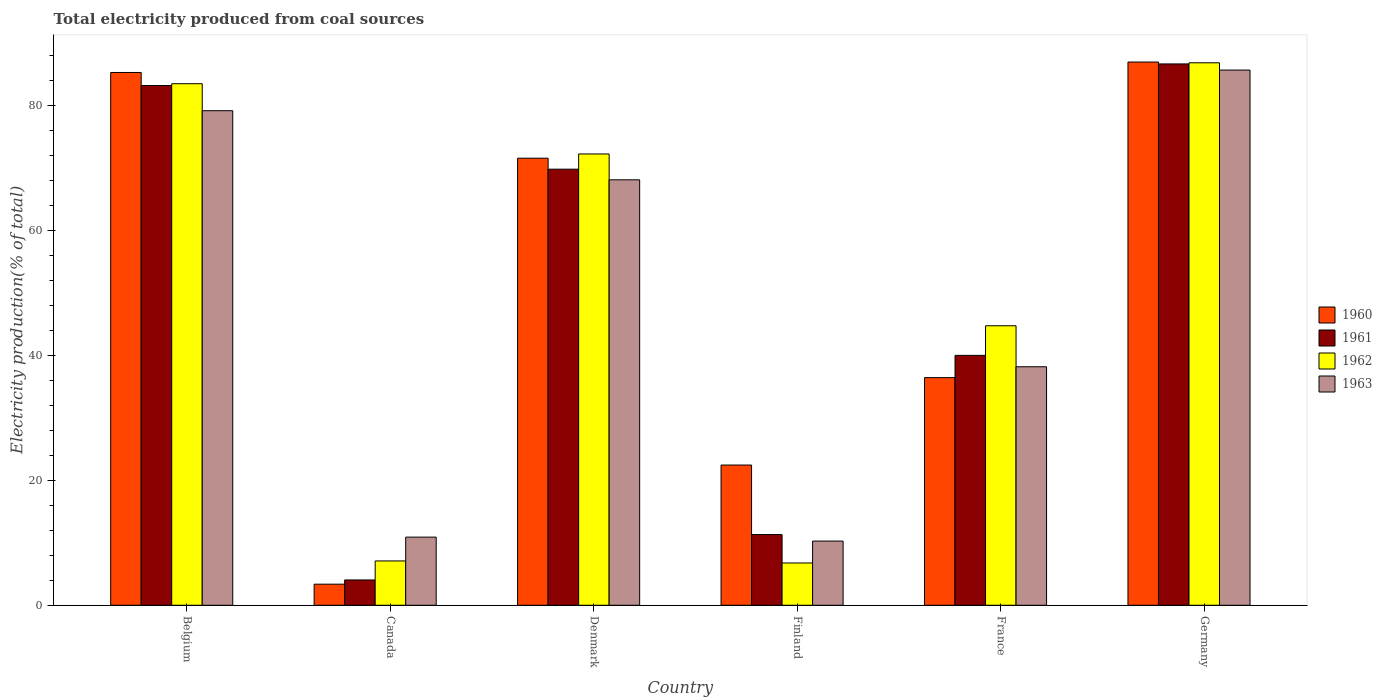How many groups of bars are there?
Ensure brevity in your answer.  6. Are the number of bars per tick equal to the number of legend labels?
Make the answer very short. Yes. Are the number of bars on each tick of the X-axis equal?
Provide a succinct answer. Yes. What is the total electricity produced in 1962 in Finland?
Make the answer very short. 6.78. Across all countries, what is the maximum total electricity produced in 1961?
Your answer should be very brief. 86.73. Across all countries, what is the minimum total electricity produced in 1962?
Give a very brief answer. 6.78. In which country was the total electricity produced in 1963 maximum?
Your answer should be compact. Germany. What is the total total electricity produced in 1963 in the graph?
Offer a very short reply. 292.54. What is the difference between the total electricity produced in 1960 in France and that in Germany?
Provide a short and direct response. -50.56. What is the difference between the total electricity produced in 1960 in Germany and the total electricity produced in 1962 in Canada?
Give a very brief answer. 79.93. What is the average total electricity produced in 1963 per country?
Ensure brevity in your answer.  48.76. What is the difference between the total electricity produced of/in 1961 and total electricity produced of/in 1963 in Germany?
Keep it short and to the point. 0.98. What is the ratio of the total electricity produced in 1961 in France to that in Germany?
Provide a short and direct response. 0.46. Is the total electricity produced in 1963 in Canada less than that in Denmark?
Offer a terse response. Yes. Is the difference between the total electricity produced in 1961 in Finland and Germany greater than the difference between the total electricity produced in 1963 in Finland and Germany?
Provide a short and direct response. Yes. What is the difference between the highest and the second highest total electricity produced in 1961?
Provide a short and direct response. 13.4. What is the difference between the highest and the lowest total electricity produced in 1962?
Provide a succinct answer. 80.13. In how many countries, is the total electricity produced in 1961 greater than the average total electricity produced in 1961 taken over all countries?
Make the answer very short. 3. What does the 4th bar from the left in Finland represents?
Provide a short and direct response. 1963. What does the 2nd bar from the right in Germany represents?
Your answer should be very brief. 1962. Is it the case that in every country, the sum of the total electricity produced in 1960 and total electricity produced in 1962 is greater than the total electricity produced in 1961?
Your answer should be very brief. Yes. How many bars are there?
Your answer should be compact. 24. Are all the bars in the graph horizontal?
Make the answer very short. No. What is the difference between two consecutive major ticks on the Y-axis?
Your answer should be compact. 20. Does the graph contain any zero values?
Give a very brief answer. No. Where does the legend appear in the graph?
Offer a very short reply. Center right. How many legend labels are there?
Your response must be concise. 4. What is the title of the graph?
Keep it short and to the point. Total electricity produced from coal sources. Does "2015" appear as one of the legend labels in the graph?
Your answer should be very brief. No. What is the label or title of the X-axis?
Keep it short and to the point. Country. What is the Electricity production(% of total) of 1960 in Belgium?
Give a very brief answer. 85.36. What is the Electricity production(% of total) in 1961 in Belgium?
Give a very brief answer. 83.27. What is the Electricity production(% of total) in 1962 in Belgium?
Keep it short and to the point. 83.56. What is the Electricity production(% of total) in 1963 in Belgium?
Keep it short and to the point. 79.23. What is the Electricity production(% of total) of 1960 in Canada?
Keep it short and to the point. 3.38. What is the Electricity production(% of total) in 1961 in Canada?
Make the answer very short. 4.05. What is the Electricity production(% of total) in 1962 in Canada?
Offer a very short reply. 7.1. What is the Electricity production(% of total) in 1963 in Canada?
Offer a very short reply. 10.92. What is the Electricity production(% of total) in 1960 in Denmark?
Provide a succinct answer. 71.62. What is the Electricity production(% of total) in 1961 in Denmark?
Give a very brief answer. 69.86. What is the Electricity production(% of total) in 1962 in Denmark?
Your response must be concise. 72.3. What is the Electricity production(% of total) in 1963 in Denmark?
Your answer should be compact. 68.16. What is the Electricity production(% of total) of 1960 in Finland?
Make the answer very short. 22.46. What is the Electricity production(% of total) of 1961 in Finland?
Offer a terse response. 11.33. What is the Electricity production(% of total) of 1962 in Finland?
Provide a succinct answer. 6.78. What is the Electricity production(% of total) of 1963 in Finland?
Offer a terse response. 10.28. What is the Electricity production(% of total) in 1960 in France?
Offer a terse response. 36.47. What is the Electricity production(% of total) in 1961 in France?
Your answer should be very brief. 40.03. What is the Electricity production(% of total) of 1962 in France?
Offer a terse response. 44.78. What is the Electricity production(% of total) in 1963 in France?
Give a very brief answer. 38.21. What is the Electricity production(% of total) in 1960 in Germany?
Provide a succinct answer. 87.03. What is the Electricity production(% of total) in 1961 in Germany?
Offer a terse response. 86.73. What is the Electricity production(% of total) in 1962 in Germany?
Make the answer very short. 86.91. What is the Electricity production(% of total) of 1963 in Germany?
Your answer should be compact. 85.74. Across all countries, what is the maximum Electricity production(% of total) in 1960?
Your response must be concise. 87.03. Across all countries, what is the maximum Electricity production(% of total) in 1961?
Your response must be concise. 86.73. Across all countries, what is the maximum Electricity production(% of total) in 1962?
Make the answer very short. 86.91. Across all countries, what is the maximum Electricity production(% of total) of 1963?
Ensure brevity in your answer.  85.74. Across all countries, what is the minimum Electricity production(% of total) in 1960?
Your response must be concise. 3.38. Across all countries, what is the minimum Electricity production(% of total) in 1961?
Provide a short and direct response. 4.05. Across all countries, what is the minimum Electricity production(% of total) of 1962?
Make the answer very short. 6.78. Across all countries, what is the minimum Electricity production(% of total) in 1963?
Offer a very short reply. 10.28. What is the total Electricity production(% of total) of 1960 in the graph?
Keep it short and to the point. 306.32. What is the total Electricity production(% of total) in 1961 in the graph?
Ensure brevity in your answer.  295.27. What is the total Electricity production(% of total) of 1962 in the graph?
Your answer should be compact. 301.42. What is the total Electricity production(% of total) in 1963 in the graph?
Provide a succinct answer. 292.55. What is the difference between the Electricity production(% of total) in 1960 in Belgium and that in Canada?
Offer a terse response. 81.98. What is the difference between the Electricity production(% of total) of 1961 in Belgium and that in Canada?
Provide a succinct answer. 79.21. What is the difference between the Electricity production(% of total) in 1962 in Belgium and that in Canada?
Give a very brief answer. 76.46. What is the difference between the Electricity production(% of total) in 1963 in Belgium and that in Canada?
Your answer should be very brief. 68.31. What is the difference between the Electricity production(% of total) of 1960 in Belgium and that in Denmark?
Provide a succinct answer. 13.73. What is the difference between the Electricity production(% of total) in 1961 in Belgium and that in Denmark?
Keep it short and to the point. 13.4. What is the difference between the Electricity production(% of total) of 1962 in Belgium and that in Denmark?
Ensure brevity in your answer.  11.26. What is the difference between the Electricity production(% of total) in 1963 in Belgium and that in Denmark?
Keep it short and to the point. 11.07. What is the difference between the Electricity production(% of total) of 1960 in Belgium and that in Finland?
Your response must be concise. 62.89. What is the difference between the Electricity production(% of total) in 1961 in Belgium and that in Finland?
Offer a terse response. 71.94. What is the difference between the Electricity production(% of total) of 1962 in Belgium and that in Finland?
Make the answer very short. 76.78. What is the difference between the Electricity production(% of total) of 1963 in Belgium and that in Finland?
Provide a succinct answer. 68.95. What is the difference between the Electricity production(% of total) of 1960 in Belgium and that in France?
Offer a terse response. 48.89. What is the difference between the Electricity production(% of total) of 1961 in Belgium and that in France?
Provide a succinct answer. 43.23. What is the difference between the Electricity production(% of total) in 1962 in Belgium and that in France?
Your response must be concise. 38.78. What is the difference between the Electricity production(% of total) of 1963 in Belgium and that in France?
Your answer should be compact. 41.02. What is the difference between the Electricity production(% of total) of 1960 in Belgium and that in Germany?
Make the answer very short. -1.67. What is the difference between the Electricity production(% of total) of 1961 in Belgium and that in Germany?
Provide a succinct answer. -3.46. What is the difference between the Electricity production(% of total) of 1962 in Belgium and that in Germany?
Make the answer very short. -3.35. What is the difference between the Electricity production(% of total) in 1963 in Belgium and that in Germany?
Provide a short and direct response. -6.51. What is the difference between the Electricity production(% of total) in 1960 in Canada and that in Denmark?
Make the answer very short. -68.25. What is the difference between the Electricity production(% of total) in 1961 in Canada and that in Denmark?
Make the answer very short. -65.81. What is the difference between the Electricity production(% of total) of 1962 in Canada and that in Denmark?
Provide a succinct answer. -65.2. What is the difference between the Electricity production(% of total) of 1963 in Canada and that in Denmark?
Provide a short and direct response. -57.24. What is the difference between the Electricity production(% of total) in 1960 in Canada and that in Finland?
Your answer should be compact. -19.09. What is the difference between the Electricity production(% of total) of 1961 in Canada and that in Finland?
Offer a terse response. -7.27. What is the difference between the Electricity production(% of total) of 1962 in Canada and that in Finland?
Provide a succinct answer. 0.32. What is the difference between the Electricity production(% of total) of 1963 in Canada and that in Finland?
Give a very brief answer. 0.63. What is the difference between the Electricity production(% of total) of 1960 in Canada and that in France?
Keep it short and to the point. -33.09. What is the difference between the Electricity production(% of total) of 1961 in Canada and that in France?
Provide a succinct answer. -35.98. What is the difference between the Electricity production(% of total) in 1962 in Canada and that in France?
Provide a succinct answer. -37.68. What is the difference between the Electricity production(% of total) of 1963 in Canada and that in France?
Ensure brevity in your answer.  -27.29. What is the difference between the Electricity production(% of total) in 1960 in Canada and that in Germany?
Ensure brevity in your answer.  -83.65. What is the difference between the Electricity production(% of total) in 1961 in Canada and that in Germany?
Your answer should be very brief. -82.67. What is the difference between the Electricity production(% of total) in 1962 in Canada and that in Germany?
Your answer should be very brief. -79.81. What is the difference between the Electricity production(% of total) of 1963 in Canada and that in Germany?
Offer a terse response. -74.83. What is the difference between the Electricity production(% of total) of 1960 in Denmark and that in Finland?
Ensure brevity in your answer.  49.16. What is the difference between the Electricity production(% of total) of 1961 in Denmark and that in Finland?
Keep it short and to the point. 58.54. What is the difference between the Electricity production(% of total) in 1962 in Denmark and that in Finland?
Provide a short and direct response. 65.53. What is the difference between the Electricity production(% of total) in 1963 in Denmark and that in Finland?
Ensure brevity in your answer.  57.88. What is the difference between the Electricity production(% of total) of 1960 in Denmark and that in France?
Keep it short and to the point. 35.16. What is the difference between the Electricity production(% of total) of 1961 in Denmark and that in France?
Offer a terse response. 29.83. What is the difference between the Electricity production(% of total) in 1962 in Denmark and that in France?
Offer a very short reply. 27.52. What is the difference between the Electricity production(% of total) of 1963 in Denmark and that in France?
Your response must be concise. 29.95. What is the difference between the Electricity production(% of total) in 1960 in Denmark and that in Germany?
Provide a short and direct response. -15.4. What is the difference between the Electricity production(% of total) in 1961 in Denmark and that in Germany?
Provide a succinct answer. -16.86. What is the difference between the Electricity production(% of total) of 1962 in Denmark and that in Germany?
Your answer should be compact. -14.61. What is the difference between the Electricity production(% of total) of 1963 in Denmark and that in Germany?
Keep it short and to the point. -17.58. What is the difference between the Electricity production(% of total) of 1960 in Finland and that in France?
Ensure brevity in your answer.  -14.01. What is the difference between the Electricity production(% of total) in 1961 in Finland and that in France?
Your answer should be compact. -28.71. What is the difference between the Electricity production(% of total) in 1962 in Finland and that in France?
Provide a succinct answer. -38. What is the difference between the Electricity production(% of total) of 1963 in Finland and that in France?
Your response must be concise. -27.93. What is the difference between the Electricity production(% of total) in 1960 in Finland and that in Germany?
Give a very brief answer. -64.57. What is the difference between the Electricity production(% of total) of 1961 in Finland and that in Germany?
Provide a succinct answer. -75.4. What is the difference between the Electricity production(% of total) in 1962 in Finland and that in Germany?
Keep it short and to the point. -80.13. What is the difference between the Electricity production(% of total) of 1963 in Finland and that in Germany?
Your answer should be very brief. -75.46. What is the difference between the Electricity production(% of total) in 1960 in France and that in Germany?
Your answer should be very brief. -50.56. What is the difference between the Electricity production(% of total) of 1961 in France and that in Germany?
Your answer should be very brief. -46.69. What is the difference between the Electricity production(% of total) in 1962 in France and that in Germany?
Ensure brevity in your answer.  -42.13. What is the difference between the Electricity production(% of total) of 1963 in France and that in Germany?
Your answer should be compact. -47.53. What is the difference between the Electricity production(% of total) of 1960 in Belgium and the Electricity production(% of total) of 1961 in Canada?
Provide a short and direct response. 81.3. What is the difference between the Electricity production(% of total) in 1960 in Belgium and the Electricity production(% of total) in 1962 in Canada?
Provide a short and direct response. 78.26. What is the difference between the Electricity production(% of total) of 1960 in Belgium and the Electricity production(% of total) of 1963 in Canada?
Your answer should be very brief. 74.44. What is the difference between the Electricity production(% of total) of 1961 in Belgium and the Electricity production(% of total) of 1962 in Canada?
Provide a succinct answer. 76.17. What is the difference between the Electricity production(% of total) of 1961 in Belgium and the Electricity production(% of total) of 1963 in Canada?
Your answer should be compact. 72.35. What is the difference between the Electricity production(% of total) in 1962 in Belgium and the Electricity production(% of total) in 1963 in Canada?
Give a very brief answer. 72.64. What is the difference between the Electricity production(% of total) of 1960 in Belgium and the Electricity production(% of total) of 1961 in Denmark?
Keep it short and to the point. 15.49. What is the difference between the Electricity production(% of total) of 1960 in Belgium and the Electricity production(% of total) of 1962 in Denmark?
Your answer should be very brief. 13.05. What is the difference between the Electricity production(% of total) of 1960 in Belgium and the Electricity production(% of total) of 1963 in Denmark?
Your response must be concise. 17.19. What is the difference between the Electricity production(% of total) of 1961 in Belgium and the Electricity production(% of total) of 1962 in Denmark?
Your answer should be very brief. 10.97. What is the difference between the Electricity production(% of total) in 1961 in Belgium and the Electricity production(% of total) in 1963 in Denmark?
Your answer should be compact. 15.11. What is the difference between the Electricity production(% of total) of 1962 in Belgium and the Electricity production(% of total) of 1963 in Denmark?
Offer a very short reply. 15.4. What is the difference between the Electricity production(% of total) in 1960 in Belgium and the Electricity production(% of total) in 1961 in Finland?
Provide a short and direct response. 74.03. What is the difference between the Electricity production(% of total) in 1960 in Belgium and the Electricity production(% of total) in 1962 in Finland?
Keep it short and to the point. 78.58. What is the difference between the Electricity production(% of total) in 1960 in Belgium and the Electricity production(% of total) in 1963 in Finland?
Your answer should be compact. 75.07. What is the difference between the Electricity production(% of total) of 1961 in Belgium and the Electricity production(% of total) of 1962 in Finland?
Provide a short and direct response. 76.49. What is the difference between the Electricity production(% of total) of 1961 in Belgium and the Electricity production(% of total) of 1963 in Finland?
Your answer should be very brief. 72.98. What is the difference between the Electricity production(% of total) in 1962 in Belgium and the Electricity production(% of total) in 1963 in Finland?
Your response must be concise. 73.27. What is the difference between the Electricity production(% of total) in 1960 in Belgium and the Electricity production(% of total) in 1961 in France?
Ensure brevity in your answer.  45.32. What is the difference between the Electricity production(% of total) in 1960 in Belgium and the Electricity production(% of total) in 1962 in France?
Provide a succinct answer. 40.58. What is the difference between the Electricity production(% of total) of 1960 in Belgium and the Electricity production(% of total) of 1963 in France?
Provide a succinct answer. 47.14. What is the difference between the Electricity production(% of total) of 1961 in Belgium and the Electricity production(% of total) of 1962 in France?
Keep it short and to the point. 38.49. What is the difference between the Electricity production(% of total) of 1961 in Belgium and the Electricity production(% of total) of 1963 in France?
Provide a short and direct response. 45.06. What is the difference between the Electricity production(% of total) in 1962 in Belgium and the Electricity production(% of total) in 1963 in France?
Offer a terse response. 45.35. What is the difference between the Electricity production(% of total) of 1960 in Belgium and the Electricity production(% of total) of 1961 in Germany?
Offer a terse response. -1.37. What is the difference between the Electricity production(% of total) of 1960 in Belgium and the Electricity production(% of total) of 1962 in Germany?
Provide a short and direct response. -1.55. What is the difference between the Electricity production(% of total) of 1960 in Belgium and the Electricity production(% of total) of 1963 in Germany?
Ensure brevity in your answer.  -0.39. What is the difference between the Electricity production(% of total) of 1961 in Belgium and the Electricity production(% of total) of 1962 in Germany?
Your answer should be compact. -3.64. What is the difference between the Electricity production(% of total) of 1961 in Belgium and the Electricity production(% of total) of 1963 in Germany?
Offer a terse response. -2.47. What is the difference between the Electricity production(% of total) in 1962 in Belgium and the Electricity production(% of total) in 1963 in Germany?
Your response must be concise. -2.19. What is the difference between the Electricity production(% of total) in 1960 in Canada and the Electricity production(% of total) in 1961 in Denmark?
Keep it short and to the point. -66.49. What is the difference between the Electricity production(% of total) of 1960 in Canada and the Electricity production(% of total) of 1962 in Denmark?
Keep it short and to the point. -68.92. What is the difference between the Electricity production(% of total) in 1960 in Canada and the Electricity production(% of total) in 1963 in Denmark?
Provide a short and direct response. -64.78. What is the difference between the Electricity production(% of total) in 1961 in Canada and the Electricity production(% of total) in 1962 in Denmark?
Provide a short and direct response. -68.25. What is the difference between the Electricity production(% of total) of 1961 in Canada and the Electricity production(% of total) of 1963 in Denmark?
Your response must be concise. -64.11. What is the difference between the Electricity production(% of total) in 1962 in Canada and the Electricity production(% of total) in 1963 in Denmark?
Keep it short and to the point. -61.06. What is the difference between the Electricity production(% of total) in 1960 in Canada and the Electricity production(% of total) in 1961 in Finland?
Your answer should be very brief. -7.95. What is the difference between the Electricity production(% of total) of 1960 in Canada and the Electricity production(% of total) of 1962 in Finland?
Your response must be concise. -3.4. What is the difference between the Electricity production(% of total) in 1960 in Canada and the Electricity production(% of total) in 1963 in Finland?
Your response must be concise. -6.91. What is the difference between the Electricity production(% of total) of 1961 in Canada and the Electricity production(% of total) of 1962 in Finland?
Your response must be concise. -2.72. What is the difference between the Electricity production(% of total) in 1961 in Canada and the Electricity production(% of total) in 1963 in Finland?
Ensure brevity in your answer.  -6.23. What is the difference between the Electricity production(% of total) of 1962 in Canada and the Electricity production(% of total) of 1963 in Finland?
Make the answer very short. -3.18. What is the difference between the Electricity production(% of total) of 1960 in Canada and the Electricity production(% of total) of 1961 in France?
Provide a short and direct response. -36.66. What is the difference between the Electricity production(% of total) in 1960 in Canada and the Electricity production(% of total) in 1962 in France?
Keep it short and to the point. -41.4. What is the difference between the Electricity production(% of total) of 1960 in Canada and the Electricity production(% of total) of 1963 in France?
Your response must be concise. -34.83. What is the difference between the Electricity production(% of total) of 1961 in Canada and the Electricity production(% of total) of 1962 in France?
Your answer should be compact. -40.72. What is the difference between the Electricity production(% of total) of 1961 in Canada and the Electricity production(% of total) of 1963 in France?
Give a very brief answer. -34.16. What is the difference between the Electricity production(% of total) in 1962 in Canada and the Electricity production(% of total) in 1963 in France?
Your answer should be compact. -31.11. What is the difference between the Electricity production(% of total) in 1960 in Canada and the Electricity production(% of total) in 1961 in Germany?
Make the answer very short. -83.35. What is the difference between the Electricity production(% of total) of 1960 in Canada and the Electricity production(% of total) of 1962 in Germany?
Provide a short and direct response. -83.53. What is the difference between the Electricity production(% of total) in 1960 in Canada and the Electricity production(% of total) in 1963 in Germany?
Ensure brevity in your answer.  -82.36. What is the difference between the Electricity production(% of total) of 1961 in Canada and the Electricity production(% of total) of 1962 in Germany?
Provide a short and direct response. -82.86. What is the difference between the Electricity production(% of total) of 1961 in Canada and the Electricity production(% of total) of 1963 in Germany?
Make the answer very short. -81.69. What is the difference between the Electricity production(% of total) in 1962 in Canada and the Electricity production(% of total) in 1963 in Germany?
Keep it short and to the point. -78.64. What is the difference between the Electricity production(% of total) of 1960 in Denmark and the Electricity production(% of total) of 1961 in Finland?
Offer a very short reply. 60.3. What is the difference between the Electricity production(% of total) of 1960 in Denmark and the Electricity production(% of total) of 1962 in Finland?
Your answer should be compact. 64.85. What is the difference between the Electricity production(% of total) of 1960 in Denmark and the Electricity production(% of total) of 1963 in Finland?
Offer a terse response. 61.34. What is the difference between the Electricity production(% of total) of 1961 in Denmark and the Electricity production(% of total) of 1962 in Finland?
Offer a very short reply. 63.09. What is the difference between the Electricity production(% of total) in 1961 in Denmark and the Electricity production(% of total) in 1963 in Finland?
Ensure brevity in your answer.  59.58. What is the difference between the Electricity production(% of total) in 1962 in Denmark and the Electricity production(% of total) in 1963 in Finland?
Ensure brevity in your answer.  62.02. What is the difference between the Electricity production(% of total) of 1960 in Denmark and the Electricity production(% of total) of 1961 in France?
Make the answer very short. 31.59. What is the difference between the Electricity production(% of total) in 1960 in Denmark and the Electricity production(% of total) in 1962 in France?
Provide a succinct answer. 26.85. What is the difference between the Electricity production(% of total) in 1960 in Denmark and the Electricity production(% of total) in 1963 in France?
Ensure brevity in your answer.  33.41. What is the difference between the Electricity production(% of total) of 1961 in Denmark and the Electricity production(% of total) of 1962 in France?
Offer a terse response. 25.09. What is the difference between the Electricity production(% of total) of 1961 in Denmark and the Electricity production(% of total) of 1963 in France?
Provide a succinct answer. 31.65. What is the difference between the Electricity production(% of total) in 1962 in Denmark and the Electricity production(% of total) in 1963 in France?
Make the answer very short. 34.09. What is the difference between the Electricity production(% of total) in 1960 in Denmark and the Electricity production(% of total) in 1961 in Germany?
Your answer should be compact. -15.1. What is the difference between the Electricity production(% of total) in 1960 in Denmark and the Electricity production(% of total) in 1962 in Germany?
Your answer should be compact. -15.28. What is the difference between the Electricity production(% of total) of 1960 in Denmark and the Electricity production(% of total) of 1963 in Germany?
Give a very brief answer. -14.12. What is the difference between the Electricity production(% of total) in 1961 in Denmark and the Electricity production(% of total) in 1962 in Germany?
Offer a terse response. -17.04. What is the difference between the Electricity production(% of total) in 1961 in Denmark and the Electricity production(% of total) in 1963 in Germany?
Offer a very short reply. -15.88. What is the difference between the Electricity production(% of total) of 1962 in Denmark and the Electricity production(% of total) of 1963 in Germany?
Offer a very short reply. -13.44. What is the difference between the Electricity production(% of total) in 1960 in Finland and the Electricity production(% of total) in 1961 in France?
Your answer should be very brief. -17.57. What is the difference between the Electricity production(% of total) in 1960 in Finland and the Electricity production(% of total) in 1962 in France?
Offer a terse response. -22.31. What is the difference between the Electricity production(% of total) of 1960 in Finland and the Electricity production(% of total) of 1963 in France?
Give a very brief answer. -15.75. What is the difference between the Electricity production(% of total) in 1961 in Finland and the Electricity production(% of total) in 1962 in France?
Offer a very short reply. -33.45. What is the difference between the Electricity production(% of total) in 1961 in Finland and the Electricity production(% of total) in 1963 in France?
Keep it short and to the point. -26.88. What is the difference between the Electricity production(% of total) in 1962 in Finland and the Electricity production(% of total) in 1963 in France?
Ensure brevity in your answer.  -31.44. What is the difference between the Electricity production(% of total) of 1960 in Finland and the Electricity production(% of total) of 1961 in Germany?
Your answer should be very brief. -64.26. What is the difference between the Electricity production(% of total) in 1960 in Finland and the Electricity production(% of total) in 1962 in Germany?
Make the answer very short. -64.45. What is the difference between the Electricity production(% of total) in 1960 in Finland and the Electricity production(% of total) in 1963 in Germany?
Provide a short and direct response. -63.28. What is the difference between the Electricity production(% of total) in 1961 in Finland and the Electricity production(% of total) in 1962 in Germany?
Provide a succinct answer. -75.58. What is the difference between the Electricity production(% of total) of 1961 in Finland and the Electricity production(% of total) of 1963 in Germany?
Your response must be concise. -74.41. What is the difference between the Electricity production(% of total) in 1962 in Finland and the Electricity production(% of total) in 1963 in Germany?
Your response must be concise. -78.97. What is the difference between the Electricity production(% of total) in 1960 in France and the Electricity production(% of total) in 1961 in Germany?
Provide a succinct answer. -50.26. What is the difference between the Electricity production(% of total) of 1960 in France and the Electricity production(% of total) of 1962 in Germany?
Give a very brief answer. -50.44. What is the difference between the Electricity production(% of total) of 1960 in France and the Electricity production(% of total) of 1963 in Germany?
Provide a succinct answer. -49.27. What is the difference between the Electricity production(% of total) of 1961 in France and the Electricity production(% of total) of 1962 in Germany?
Keep it short and to the point. -46.87. What is the difference between the Electricity production(% of total) of 1961 in France and the Electricity production(% of total) of 1963 in Germany?
Ensure brevity in your answer.  -45.71. What is the difference between the Electricity production(% of total) in 1962 in France and the Electricity production(% of total) in 1963 in Germany?
Provide a short and direct response. -40.97. What is the average Electricity production(% of total) of 1960 per country?
Give a very brief answer. 51.05. What is the average Electricity production(% of total) in 1961 per country?
Ensure brevity in your answer.  49.21. What is the average Electricity production(% of total) of 1962 per country?
Offer a very short reply. 50.24. What is the average Electricity production(% of total) of 1963 per country?
Offer a very short reply. 48.76. What is the difference between the Electricity production(% of total) in 1960 and Electricity production(% of total) in 1961 in Belgium?
Make the answer very short. 2.09. What is the difference between the Electricity production(% of total) in 1960 and Electricity production(% of total) in 1962 in Belgium?
Give a very brief answer. 1.8. What is the difference between the Electricity production(% of total) of 1960 and Electricity production(% of total) of 1963 in Belgium?
Make the answer very short. 6.12. What is the difference between the Electricity production(% of total) in 1961 and Electricity production(% of total) in 1962 in Belgium?
Your response must be concise. -0.29. What is the difference between the Electricity production(% of total) in 1961 and Electricity production(% of total) in 1963 in Belgium?
Give a very brief answer. 4.04. What is the difference between the Electricity production(% of total) in 1962 and Electricity production(% of total) in 1963 in Belgium?
Offer a terse response. 4.33. What is the difference between the Electricity production(% of total) of 1960 and Electricity production(% of total) of 1961 in Canada?
Keep it short and to the point. -0.68. What is the difference between the Electricity production(% of total) in 1960 and Electricity production(% of total) in 1962 in Canada?
Your answer should be compact. -3.72. What is the difference between the Electricity production(% of total) in 1960 and Electricity production(% of total) in 1963 in Canada?
Give a very brief answer. -7.54. What is the difference between the Electricity production(% of total) of 1961 and Electricity production(% of total) of 1962 in Canada?
Your response must be concise. -3.04. What is the difference between the Electricity production(% of total) in 1961 and Electricity production(% of total) in 1963 in Canada?
Your answer should be very brief. -6.86. What is the difference between the Electricity production(% of total) of 1962 and Electricity production(% of total) of 1963 in Canada?
Provide a succinct answer. -3.82. What is the difference between the Electricity production(% of total) of 1960 and Electricity production(% of total) of 1961 in Denmark?
Your response must be concise. 1.76. What is the difference between the Electricity production(% of total) of 1960 and Electricity production(% of total) of 1962 in Denmark?
Offer a very short reply. -0.68. What is the difference between the Electricity production(% of total) of 1960 and Electricity production(% of total) of 1963 in Denmark?
Provide a succinct answer. 3.46. What is the difference between the Electricity production(% of total) of 1961 and Electricity production(% of total) of 1962 in Denmark?
Offer a terse response. -2.44. What is the difference between the Electricity production(% of total) of 1961 and Electricity production(% of total) of 1963 in Denmark?
Offer a very short reply. 1.7. What is the difference between the Electricity production(% of total) of 1962 and Electricity production(% of total) of 1963 in Denmark?
Your answer should be very brief. 4.14. What is the difference between the Electricity production(% of total) of 1960 and Electricity production(% of total) of 1961 in Finland?
Provide a succinct answer. 11.14. What is the difference between the Electricity production(% of total) of 1960 and Electricity production(% of total) of 1962 in Finland?
Give a very brief answer. 15.69. What is the difference between the Electricity production(% of total) in 1960 and Electricity production(% of total) in 1963 in Finland?
Ensure brevity in your answer.  12.18. What is the difference between the Electricity production(% of total) in 1961 and Electricity production(% of total) in 1962 in Finland?
Offer a terse response. 4.55. What is the difference between the Electricity production(% of total) of 1961 and Electricity production(% of total) of 1963 in Finland?
Your answer should be compact. 1.04. What is the difference between the Electricity production(% of total) of 1962 and Electricity production(% of total) of 1963 in Finland?
Make the answer very short. -3.51. What is the difference between the Electricity production(% of total) in 1960 and Electricity production(% of total) in 1961 in France?
Keep it short and to the point. -3.57. What is the difference between the Electricity production(% of total) of 1960 and Electricity production(% of total) of 1962 in France?
Your answer should be very brief. -8.31. What is the difference between the Electricity production(% of total) of 1960 and Electricity production(% of total) of 1963 in France?
Your answer should be compact. -1.74. What is the difference between the Electricity production(% of total) in 1961 and Electricity production(% of total) in 1962 in France?
Your response must be concise. -4.74. What is the difference between the Electricity production(% of total) of 1961 and Electricity production(% of total) of 1963 in France?
Offer a very short reply. 1.82. What is the difference between the Electricity production(% of total) in 1962 and Electricity production(% of total) in 1963 in France?
Your answer should be compact. 6.57. What is the difference between the Electricity production(% of total) in 1960 and Electricity production(% of total) in 1961 in Germany?
Ensure brevity in your answer.  0.3. What is the difference between the Electricity production(% of total) in 1960 and Electricity production(% of total) in 1962 in Germany?
Offer a terse response. 0.12. What is the difference between the Electricity production(% of total) in 1960 and Electricity production(% of total) in 1963 in Germany?
Your answer should be very brief. 1.29. What is the difference between the Electricity production(% of total) in 1961 and Electricity production(% of total) in 1962 in Germany?
Offer a terse response. -0.18. What is the difference between the Electricity production(% of total) in 1961 and Electricity production(% of total) in 1963 in Germany?
Give a very brief answer. 0.98. What is the difference between the Electricity production(% of total) in 1962 and Electricity production(% of total) in 1963 in Germany?
Provide a short and direct response. 1.17. What is the ratio of the Electricity production(% of total) in 1960 in Belgium to that in Canada?
Offer a terse response. 25.27. What is the ratio of the Electricity production(% of total) of 1961 in Belgium to that in Canada?
Your answer should be very brief. 20.54. What is the ratio of the Electricity production(% of total) of 1962 in Belgium to that in Canada?
Offer a very short reply. 11.77. What is the ratio of the Electricity production(% of total) in 1963 in Belgium to that in Canada?
Your response must be concise. 7.26. What is the ratio of the Electricity production(% of total) of 1960 in Belgium to that in Denmark?
Offer a very short reply. 1.19. What is the ratio of the Electricity production(% of total) of 1961 in Belgium to that in Denmark?
Your answer should be very brief. 1.19. What is the ratio of the Electricity production(% of total) of 1962 in Belgium to that in Denmark?
Offer a very short reply. 1.16. What is the ratio of the Electricity production(% of total) of 1963 in Belgium to that in Denmark?
Provide a succinct answer. 1.16. What is the ratio of the Electricity production(% of total) in 1960 in Belgium to that in Finland?
Provide a succinct answer. 3.8. What is the ratio of the Electricity production(% of total) in 1961 in Belgium to that in Finland?
Provide a succinct answer. 7.35. What is the ratio of the Electricity production(% of total) in 1962 in Belgium to that in Finland?
Keep it short and to the point. 12.33. What is the ratio of the Electricity production(% of total) of 1963 in Belgium to that in Finland?
Provide a succinct answer. 7.7. What is the ratio of the Electricity production(% of total) of 1960 in Belgium to that in France?
Provide a short and direct response. 2.34. What is the ratio of the Electricity production(% of total) in 1961 in Belgium to that in France?
Keep it short and to the point. 2.08. What is the ratio of the Electricity production(% of total) in 1962 in Belgium to that in France?
Provide a short and direct response. 1.87. What is the ratio of the Electricity production(% of total) in 1963 in Belgium to that in France?
Provide a succinct answer. 2.07. What is the ratio of the Electricity production(% of total) of 1960 in Belgium to that in Germany?
Make the answer very short. 0.98. What is the ratio of the Electricity production(% of total) in 1961 in Belgium to that in Germany?
Give a very brief answer. 0.96. What is the ratio of the Electricity production(% of total) in 1962 in Belgium to that in Germany?
Offer a very short reply. 0.96. What is the ratio of the Electricity production(% of total) in 1963 in Belgium to that in Germany?
Ensure brevity in your answer.  0.92. What is the ratio of the Electricity production(% of total) in 1960 in Canada to that in Denmark?
Your response must be concise. 0.05. What is the ratio of the Electricity production(% of total) in 1961 in Canada to that in Denmark?
Your answer should be very brief. 0.06. What is the ratio of the Electricity production(% of total) in 1962 in Canada to that in Denmark?
Provide a short and direct response. 0.1. What is the ratio of the Electricity production(% of total) in 1963 in Canada to that in Denmark?
Your answer should be compact. 0.16. What is the ratio of the Electricity production(% of total) of 1960 in Canada to that in Finland?
Offer a terse response. 0.15. What is the ratio of the Electricity production(% of total) of 1961 in Canada to that in Finland?
Your answer should be compact. 0.36. What is the ratio of the Electricity production(% of total) of 1962 in Canada to that in Finland?
Offer a very short reply. 1.05. What is the ratio of the Electricity production(% of total) in 1963 in Canada to that in Finland?
Make the answer very short. 1.06. What is the ratio of the Electricity production(% of total) of 1960 in Canada to that in France?
Provide a short and direct response. 0.09. What is the ratio of the Electricity production(% of total) of 1961 in Canada to that in France?
Give a very brief answer. 0.1. What is the ratio of the Electricity production(% of total) of 1962 in Canada to that in France?
Give a very brief answer. 0.16. What is the ratio of the Electricity production(% of total) in 1963 in Canada to that in France?
Ensure brevity in your answer.  0.29. What is the ratio of the Electricity production(% of total) of 1960 in Canada to that in Germany?
Make the answer very short. 0.04. What is the ratio of the Electricity production(% of total) in 1961 in Canada to that in Germany?
Give a very brief answer. 0.05. What is the ratio of the Electricity production(% of total) of 1962 in Canada to that in Germany?
Offer a very short reply. 0.08. What is the ratio of the Electricity production(% of total) in 1963 in Canada to that in Germany?
Your answer should be compact. 0.13. What is the ratio of the Electricity production(% of total) in 1960 in Denmark to that in Finland?
Give a very brief answer. 3.19. What is the ratio of the Electricity production(% of total) of 1961 in Denmark to that in Finland?
Your answer should be compact. 6.17. What is the ratio of the Electricity production(% of total) in 1962 in Denmark to that in Finland?
Your response must be concise. 10.67. What is the ratio of the Electricity production(% of total) in 1963 in Denmark to that in Finland?
Offer a very short reply. 6.63. What is the ratio of the Electricity production(% of total) of 1960 in Denmark to that in France?
Your response must be concise. 1.96. What is the ratio of the Electricity production(% of total) of 1961 in Denmark to that in France?
Offer a very short reply. 1.75. What is the ratio of the Electricity production(% of total) in 1962 in Denmark to that in France?
Keep it short and to the point. 1.61. What is the ratio of the Electricity production(% of total) of 1963 in Denmark to that in France?
Provide a short and direct response. 1.78. What is the ratio of the Electricity production(% of total) in 1960 in Denmark to that in Germany?
Keep it short and to the point. 0.82. What is the ratio of the Electricity production(% of total) of 1961 in Denmark to that in Germany?
Make the answer very short. 0.81. What is the ratio of the Electricity production(% of total) of 1962 in Denmark to that in Germany?
Your response must be concise. 0.83. What is the ratio of the Electricity production(% of total) of 1963 in Denmark to that in Germany?
Provide a succinct answer. 0.79. What is the ratio of the Electricity production(% of total) of 1960 in Finland to that in France?
Provide a short and direct response. 0.62. What is the ratio of the Electricity production(% of total) of 1961 in Finland to that in France?
Offer a very short reply. 0.28. What is the ratio of the Electricity production(% of total) of 1962 in Finland to that in France?
Your response must be concise. 0.15. What is the ratio of the Electricity production(% of total) of 1963 in Finland to that in France?
Make the answer very short. 0.27. What is the ratio of the Electricity production(% of total) in 1960 in Finland to that in Germany?
Ensure brevity in your answer.  0.26. What is the ratio of the Electricity production(% of total) of 1961 in Finland to that in Germany?
Keep it short and to the point. 0.13. What is the ratio of the Electricity production(% of total) of 1962 in Finland to that in Germany?
Your answer should be very brief. 0.08. What is the ratio of the Electricity production(% of total) of 1963 in Finland to that in Germany?
Ensure brevity in your answer.  0.12. What is the ratio of the Electricity production(% of total) of 1960 in France to that in Germany?
Provide a succinct answer. 0.42. What is the ratio of the Electricity production(% of total) of 1961 in France to that in Germany?
Make the answer very short. 0.46. What is the ratio of the Electricity production(% of total) in 1962 in France to that in Germany?
Offer a very short reply. 0.52. What is the ratio of the Electricity production(% of total) of 1963 in France to that in Germany?
Your response must be concise. 0.45. What is the difference between the highest and the second highest Electricity production(% of total) in 1960?
Offer a terse response. 1.67. What is the difference between the highest and the second highest Electricity production(% of total) in 1961?
Your answer should be very brief. 3.46. What is the difference between the highest and the second highest Electricity production(% of total) in 1962?
Provide a short and direct response. 3.35. What is the difference between the highest and the second highest Electricity production(% of total) in 1963?
Provide a short and direct response. 6.51. What is the difference between the highest and the lowest Electricity production(% of total) of 1960?
Make the answer very short. 83.65. What is the difference between the highest and the lowest Electricity production(% of total) in 1961?
Make the answer very short. 82.67. What is the difference between the highest and the lowest Electricity production(% of total) in 1962?
Provide a short and direct response. 80.13. What is the difference between the highest and the lowest Electricity production(% of total) of 1963?
Your answer should be compact. 75.46. 